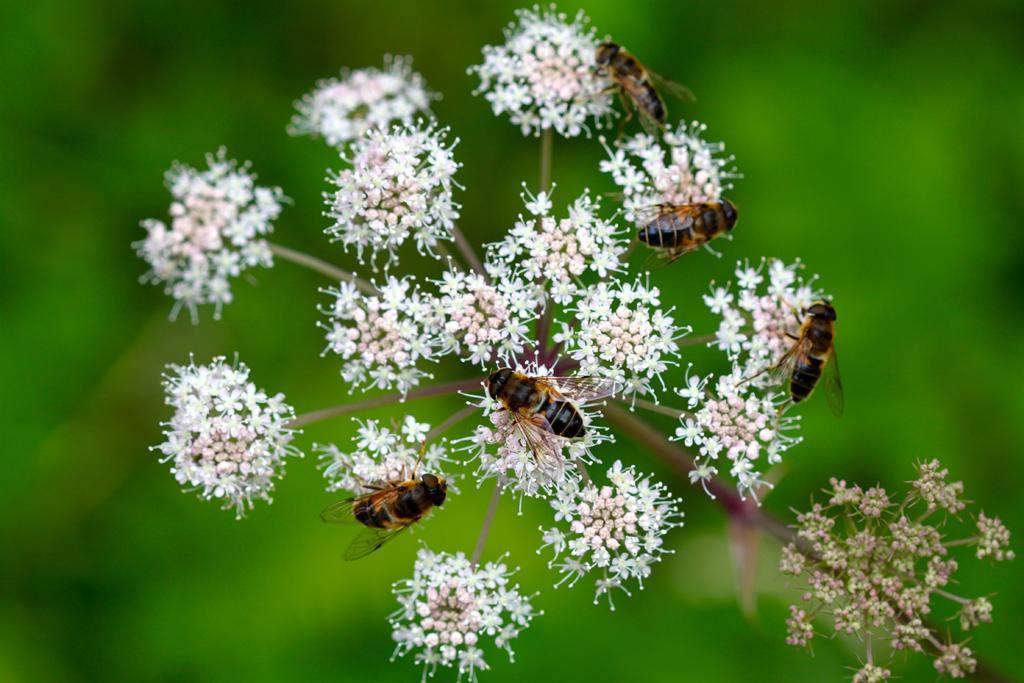Can you describe this image briefly? In this image I can see some insects on the flower. 